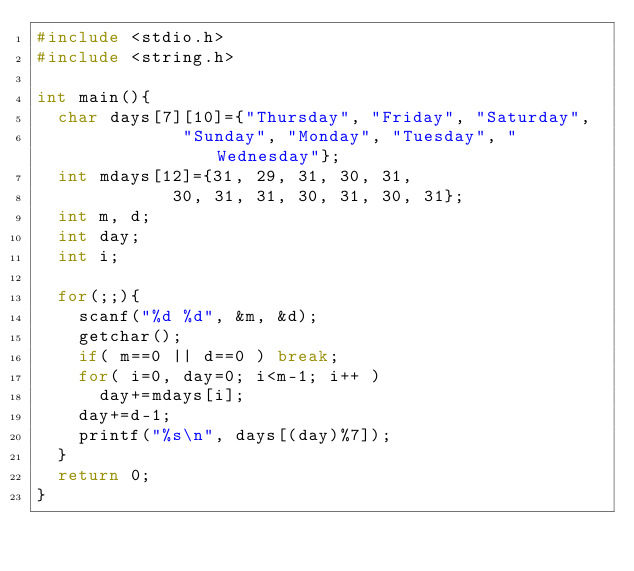Convert code to text. <code><loc_0><loc_0><loc_500><loc_500><_C_>#include <stdio.h>
#include <string.h>

int main(){
	char days[7][10]={"Thursday", "Friday", "Saturday",
							"Sunday", "Monday", "Tuesday", "Wednesday"};
	int mdays[12]={31, 29, 31, 30, 31,
						 30, 31, 31, 30, 31, 30, 31};
	int m, d;
	int day;
	int i;

	for(;;){
		scanf("%d %d", &m, &d);
		getchar();
		if( m==0 || d==0 ) break;
		for( i=0, day=0; i<m-1; i++ )
			day+=mdays[i];
		day+=d-1;
		printf("%s\n", days[(day)%7]);
	}
	return 0;
}</code> 